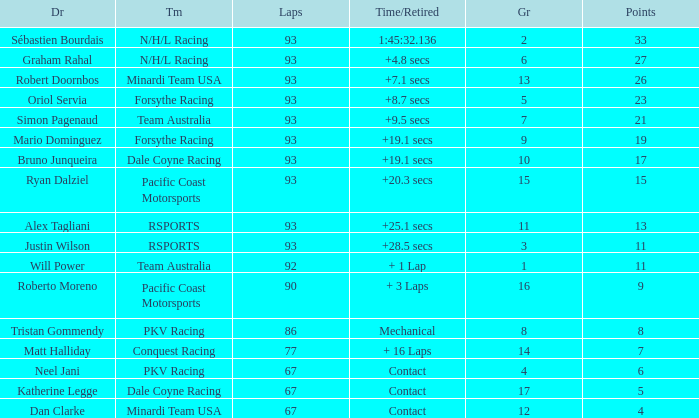Could you parse the entire table? {'header': ['Dr', 'Tm', 'Laps', 'Time/Retired', 'Gr', 'Points'], 'rows': [['Sébastien Bourdais', 'N/H/L Racing', '93', '1:45:32.136', '2', '33'], ['Graham Rahal', 'N/H/L Racing', '93', '+4.8 secs', '6', '27'], ['Robert Doornbos', 'Minardi Team USA', '93', '+7.1 secs', '13', '26'], ['Oriol Servia', 'Forsythe Racing', '93', '+8.7 secs', '5', '23'], ['Simon Pagenaud', 'Team Australia', '93', '+9.5 secs', '7', '21'], ['Mario Dominguez', 'Forsythe Racing', '93', '+19.1 secs', '9', '19'], ['Bruno Junqueira', 'Dale Coyne Racing', '93', '+19.1 secs', '10', '17'], ['Ryan Dalziel', 'Pacific Coast Motorsports', '93', '+20.3 secs', '15', '15'], ['Alex Tagliani', 'RSPORTS', '93', '+25.1 secs', '11', '13'], ['Justin Wilson', 'RSPORTS', '93', '+28.5 secs', '3', '11'], ['Will Power', 'Team Australia', '92', '+ 1 Lap', '1', '11'], ['Roberto Moreno', 'Pacific Coast Motorsports', '90', '+ 3 Laps', '16', '9'], ['Tristan Gommendy', 'PKV Racing', '86', 'Mechanical', '8', '8'], ['Matt Halliday', 'Conquest Racing', '77', '+ 16 Laps', '14', '7'], ['Neel Jani', 'PKV Racing', '67', 'Contact', '4', '6'], ['Katherine Legge', 'Dale Coyne Racing', '67', 'Contact', '17', '5'], ['Dan Clarke', 'Minardi Team USA', '67', 'Contact', '12', '4']]} What is the grid for the Minardi Team USA with laps smaller than 90? 12.0. 